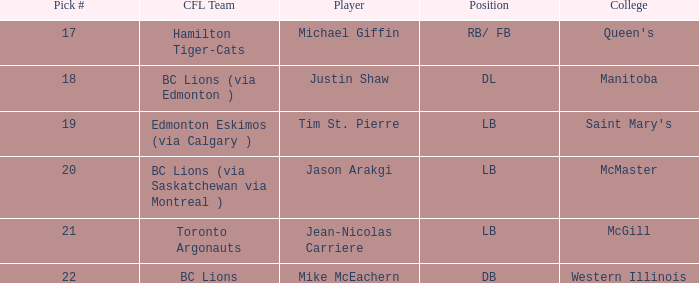How many cfl teams possessed pick # 21? 1.0. 